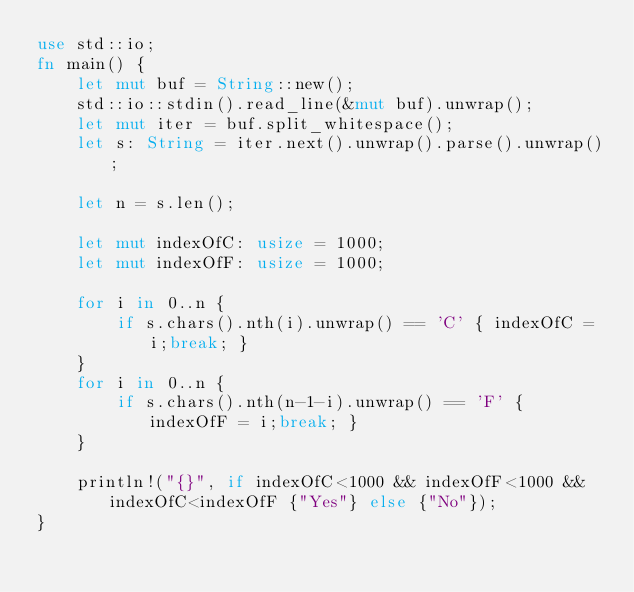<code> <loc_0><loc_0><loc_500><loc_500><_Rust_>use std::io;
fn main() {
    let mut buf = String::new();
    std::io::stdin().read_line(&mut buf).unwrap();
    let mut iter = buf.split_whitespace();
    let s: String = iter.next().unwrap().parse().unwrap();

    let n = s.len();

    let mut indexOfC: usize = 1000;
    let mut indexOfF: usize = 1000;

    for i in 0..n {
        if s.chars().nth(i).unwrap() == 'C' { indexOfC = i;break; }
    }
    for i in 0..n {
        if s.chars().nth(n-1-i).unwrap() == 'F' { indexOfF = i;break; }
    }

    println!("{}", if indexOfC<1000 && indexOfF<1000 && indexOfC<indexOfF {"Yes"} else {"No"});
}
</code> 